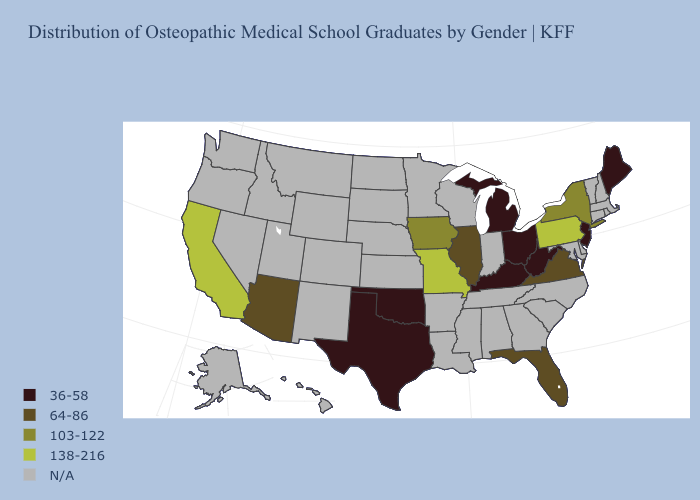Which states have the highest value in the USA?
Short answer required. California, Missouri, Pennsylvania. Which states have the lowest value in the South?
Give a very brief answer. Kentucky, Oklahoma, Texas, West Virginia. Name the states that have a value in the range N/A?
Write a very short answer. Alabama, Alaska, Arkansas, Colorado, Connecticut, Delaware, Georgia, Hawaii, Idaho, Indiana, Kansas, Louisiana, Maryland, Massachusetts, Minnesota, Mississippi, Montana, Nebraska, Nevada, New Hampshire, New Mexico, North Carolina, North Dakota, Oregon, Rhode Island, South Carolina, South Dakota, Tennessee, Utah, Vermont, Washington, Wisconsin, Wyoming. Which states have the lowest value in the USA?
Answer briefly. Kentucky, Maine, Michigan, New Jersey, Ohio, Oklahoma, Texas, West Virginia. Among the states that border Texas , which have the highest value?
Concise answer only. Oklahoma. What is the value of New Jersey?
Be succinct. 36-58. What is the value of Iowa?
Be succinct. 103-122. Does the map have missing data?
Quick response, please. Yes. Does Ohio have the lowest value in the USA?
Short answer required. Yes. What is the value of Delaware?
Be succinct. N/A. What is the value of West Virginia?
Give a very brief answer. 36-58. Does California have the lowest value in the West?
Be succinct. No. How many symbols are there in the legend?
Short answer required. 5. What is the highest value in the USA?
Write a very short answer. 138-216. 